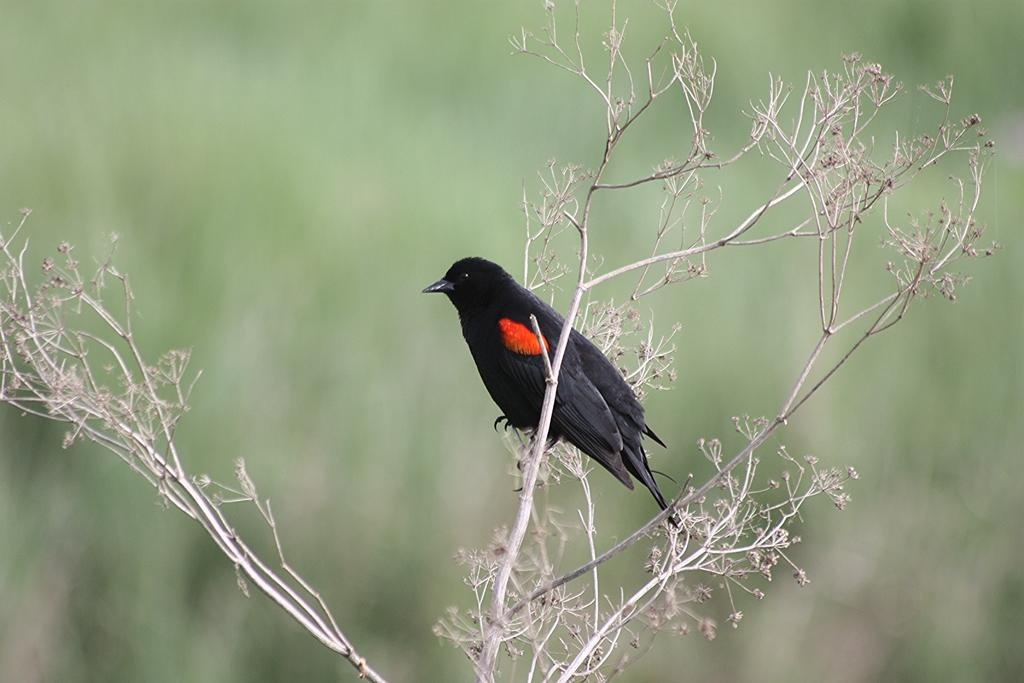What type of animal can be seen in the image? There is a bird in the image. Where is the bird located? The bird is on a plant. Can you describe the background of the image? The background of the image is blurred. What is the bird's tendency to take vacations in the image? There is no information about the bird's vacation tendencies in the image. 